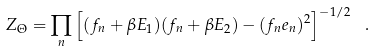Convert formula to latex. <formula><loc_0><loc_0><loc_500><loc_500>Z _ { \Theta } = \prod _ { n } \left [ ( f _ { n } + \beta E _ { 1 } ) ( f _ { n } + \beta E _ { 2 } ) - ( f _ { n } e _ { n } ) ^ { 2 } \right ] ^ { - 1 / 2 } \ .</formula> 